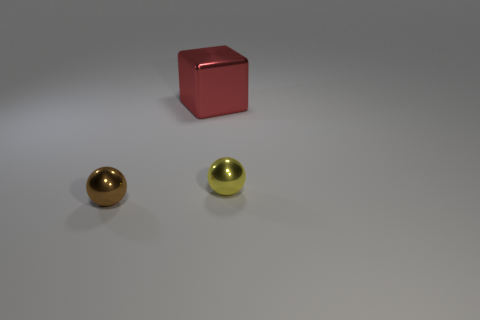Is the number of large red objects behind the red object greater than the number of tiny shiny cylinders? From observing the image, it appears that there is only one large red object and it is in the foreground, not behind any objects. There are two tiny shiny cylinders visible; therefore, the number of large red objects is not greater than the number of tiny shiny cylinders. 